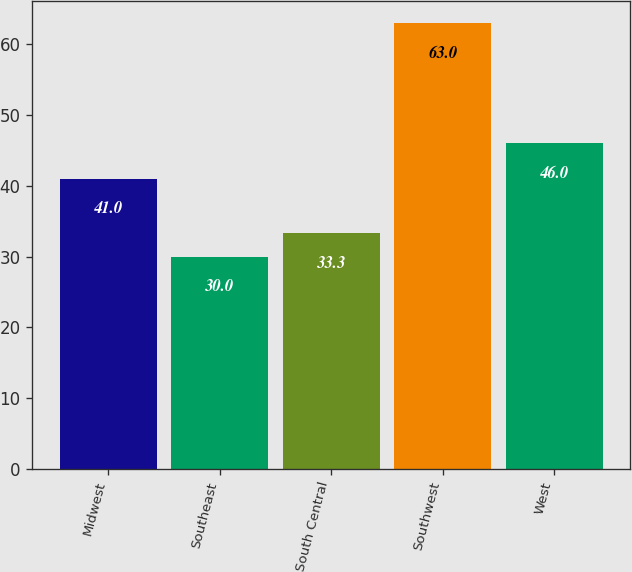Convert chart to OTSL. <chart><loc_0><loc_0><loc_500><loc_500><bar_chart><fcel>Midwest<fcel>Southeast<fcel>South Central<fcel>Southwest<fcel>West<nl><fcel>41<fcel>30<fcel>33.3<fcel>63<fcel>46<nl></chart> 